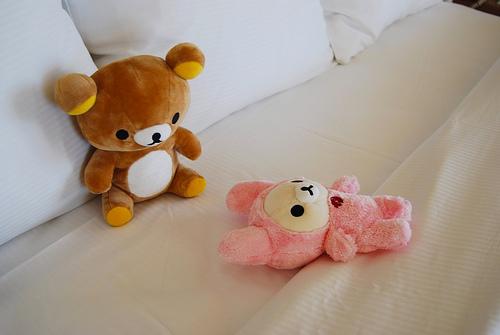Is anyone sleeping in the bed?
Answer briefly. No. How many pillows are on the bed?
Write a very short answer. 3. How many dolls are there?
Write a very short answer. 2. What is this toy made of?
Concise answer only. Cotton. Are they touching?
Concise answer only. No. How many toys are there?
Give a very brief answer. 2. Are these bears creepy or cute?
Concise answer only. Cute. 